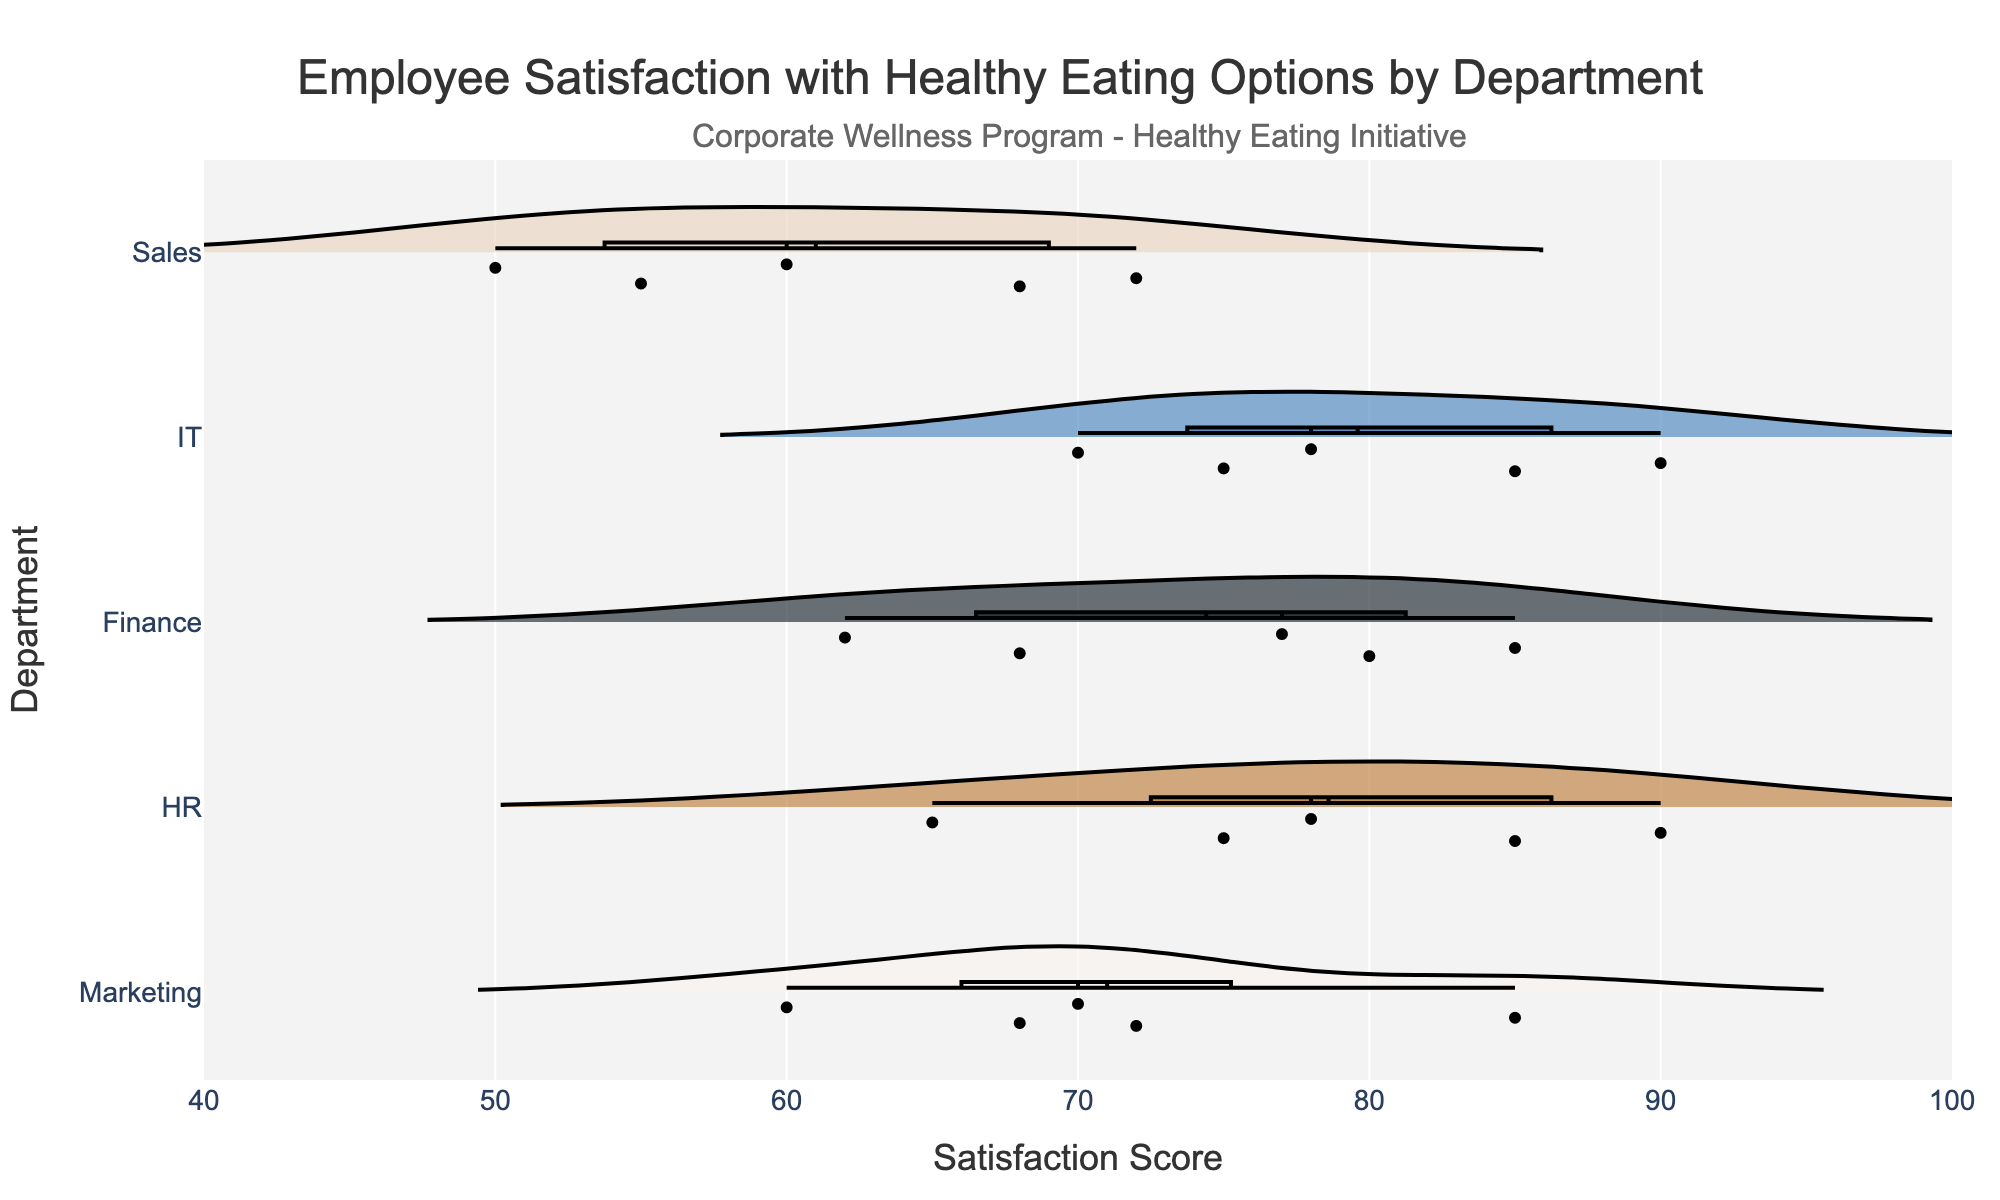What's the title of the figure? The title is usually displayed prominently at the top of the chart. It provides a brief description of what the chart represents. The title here is "Employee Satisfaction with Healthy Eating Options by Department."
Answer: Employee Satisfaction with Healthy Eating Options by Department What departments are included in the chart? The departments are listed along the y-axis of the chart. In this figure, the five departments included are Marketing, HR, Finance, IT, and Sales.
Answer: Marketing, HR, Finance, IT, Sales Which department has the widest spread in satisfaction scores? The spread can be identified by looking at the width of the violin shapes. The Sales department has a noticeably wide spread of satisfaction scores, indicating a large variability in their responses.
Answer: Sales Which department has the highest mean satisfaction score? The mean satisfaction score is depicted by a line within the violin plot. The HR department shows the highest mean satisfaction score.
Answer: HR What is the range of satisfaction scores for the IT department? The range can be deduced by looking at the maximum and minimum points of the violin plot for the IT department. The scores range from 70 to 90.
Answer: 70 to 90 How do the satisfaction scores of Marketing and Finance departments compare? Comparisons can be made by observing the similarities and differences in the shapes, widths, and data points of the violins. Both departments have similar distributions, but the Marketing department has a slightly lower central tendency compared to Finance.
Answer: Marketing has slightly lower scores than Finance What is the median satisfaction score for each department? The median is typically indicated by a central marker in the violin plot. For these departments, the median scores are: Marketing (70), HR (78), Finance (77), IT (78), and Sales (60).
Answer: Marketing: 70, HR: 78, Finance: 77, IT: 78, Sales: 60 Which department has the lowest recorded satisfaction score, and what is it? The lowest recorded scores are found at the bottom of each violin. The Sales department has the lowest recorded score, which is 50.
Answer: Sales: 50 Is there any department with a perfect score or very close to it? A perfect score would be nearest to 100. None of the departments reach a perfect score, but HR has the highest recorded score of 90, which is the highest across all departments.
Answer: No perfect score, highest is 90 in HR 